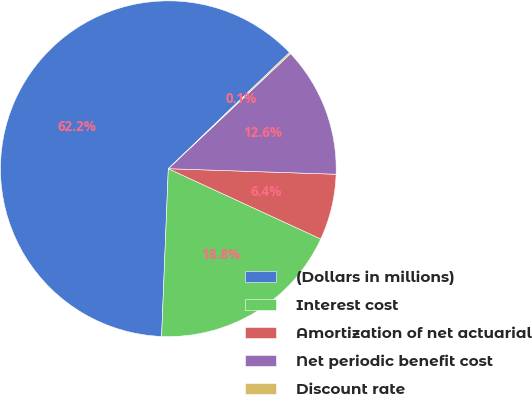Convert chart. <chart><loc_0><loc_0><loc_500><loc_500><pie_chart><fcel>(Dollars in millions)<fcel>Interest cost<fcel>Amortization of net actuarial<fcel>Net periodic benefit cost<fcel>Discount rate<nl><fcel>62.2%<fcel>18.76%<fcel>6.35%<fcel>12.55%<fcel>0.14%<nl></chart> 